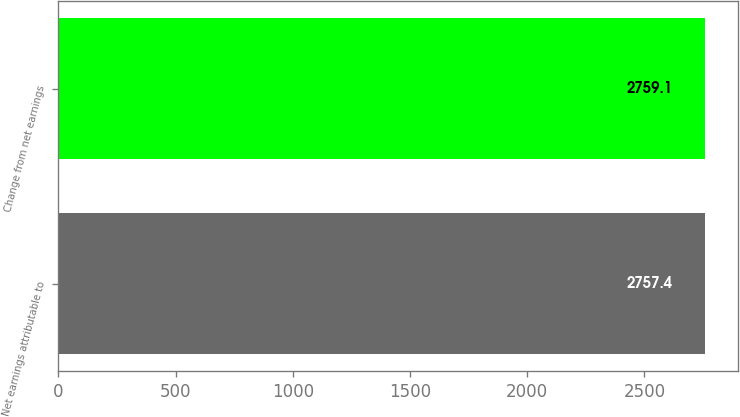<chart> <loc_0><loc_0><loc_500><loc_500><bar_chart><fcel>Net earnings attributable to<fcel>Change from net earnings<nl><fcel>2757.4<fcel>2759.1<nl></chart> 